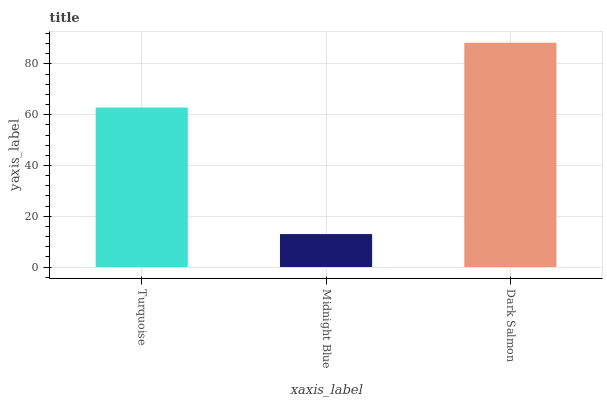Is Midnight Blue the minimum?
Answer yes or no. Yes. Is Dark Salmon the maximum?
Answer yes or no. Yes. Is Dark Salmon the minimum?
Answer yes or no. No. Is Midnight Blue the maximum?
Answer yes or no. No. Is Dark Salmon greater than Midnight Blue?
Answer yes or no. Yes. Is Midnight Blue less than Dark Salmon?
Answer yes or no. Yes. Is Midnight Blue greater than Dark Salmon?
Answer yes or no. No. Is Dark Salmon less than Midnight Blue?
Answer yes or no. No. Is Turquoise the high median?
Answer yes or no. Yes. Is Turquoise the low median?
Answer yes or no. Yes. Is Dark Salmon the high median?
Answer yes or no. No. Is Midnight Blue the low median?
Answer yes or no. No. 